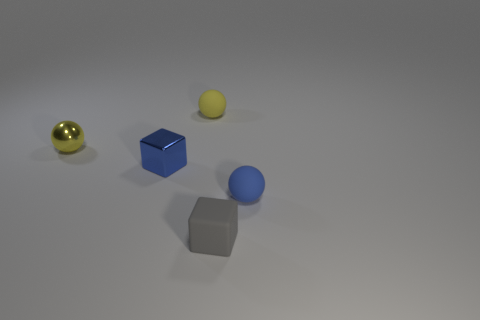Subtract all small matte spheres. How many spheres are left? 1 Add 2 large purple matte blocks. How many objects exist? 7 Subtract 1 blocks. How many blocks are left? 1 Subtract all blue balls. How many balls are left? 2 Add 1 blue rubber spheres. How many blue rubber spheres exist? 2 Subtract 0 brown balls. How many objects are left? 5 Subtract all balls. How many objects are left? 2 Subtract all red blocks. Subtract all gray spheres. How many blocks are left? 2 Subtract all blue balls. How many green blocks are left? 0 Subtract all small blue objects. Subtract all red objects. How many objects are left? 3 